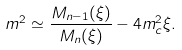Convert formula to latex. <formula><loc_0><loc_0><loc_500><loc_500>m ^ { 2 } \simeq \frac { M _ { n - 1 } ( \xi ) } { M _ { n } ( \xi ) } - 4 m _ { c } ^ { 2 } \xi .</formula> 